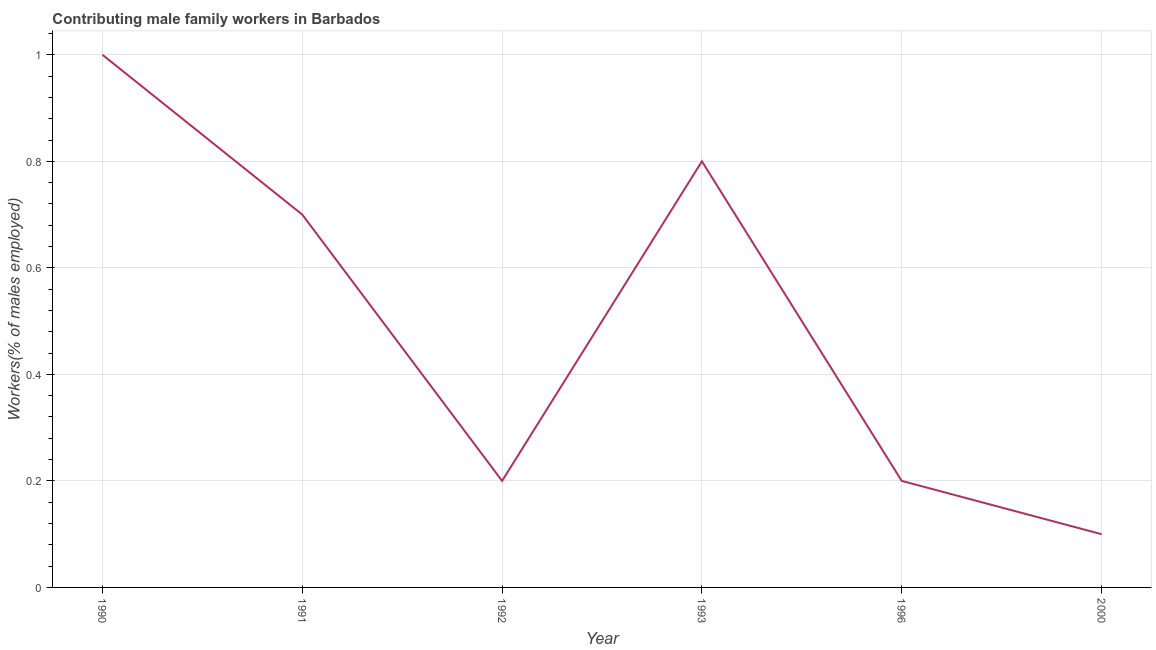Across all years, what is the minimum contributing male family workers?
Your answer should be very brief. 0.1. In which year was the contributing male family workers maximum?
Offer a terse response. 1990. In which year was the contributing male family workers minimum?
Your answer should be compact. 2000. What is the sum of the contributing male family workers?
Your answer should be very brief. 3. What is the difference between the contributing male family workers in 1991 and 1996?
Provide a short and direct response. 0.5. What is the average contributing male family workers per year?
Offer a very short reply. 0.5. What is the median contributing male family workers?
Keep it short and to the point. 0.45. Do a majority of the years between 1992 and 1991 (inclusive) have contributing male family workers greater than 0.48000000000000004 %?
Keep it short and to the point. No. What is the ratio of the contributing male family workers in 1990 to that in 2000?
Your answer should be compact. 10. What is the difference between the highest and the second highest contributing male family workers?
Keep it short and to the point. 0.2. Is the sum of the contributing male family workers in 1991 and 1992 greater than the maximum contributing male family workers across all years?
Give a very brief answer. No. What is the difference between the highest and the lowest contributing male family workers?
Your answer should be very brief. 0.9. Does the contributing male family workers monotonically increase over the years?
Keep it short and to the point. No. What is the title of the graph?
Your answer should be compact. Contributing male family workers in Barbados. What is the label or title of the X-axis?
Your answer should be compact. Year. What is the label or title of the Y-axis?
Offer a very short reply. Workers(% of males employed). What is the Workers(% of males employed) in 1990?
Make the answer very short. 1. What is the Workers(% of males employed) of 1991?
Ensure brevity in your answer.  0.7. What is the Workers(% of males employed) of 1992?
Your answer should be compact. 0.2. What is the Workers(% of males employed) in 1993?
Your response must be concise. 0.8. What is the Workers(% of males employed) in 1996?
Your answer should be compact. 0.2. What is the Workers(% of males employed) in 2000?
Provide a succinct answer. 0.1. What is the difference between the Workers(% of males employed) in 1990 and 2000?
Provide a succinct answer. 0.9. What is the difference between the Workers(% of males employed) in 1991 and 1992?
Offer a terse response. 0.5. What is the difference between the Workers(% of males employed) in 1991 and 1996?
Ensure brevity in your answer.  0.5. What is the difference between the Workers(% of males employed) in 1991 and 2000?
Provide a succinct answer. 0.6. What is the difference between the Workers(% of males employed) in 1992 and 1993?
Make the answer very short. -0.6. What is the difference between the Workers(% of males employed) in 1992 and 2000?
Ensure brevity in your answer.  0.1. What is the difference between the Workers(% of males employed) in 1993 and 2000?
Offer a terse response. 0.7. What is the difference between the Workers(% of males employed) in 1996 and 2000?
Your response must be concise. 0.1. What is the ratio of the Workers(% of males employed) in 1990 to that in 1991?
Your answer should be very brief. 1.43. What is the ratio of the Workers(% of males employed) in 1990 to that in 2000?
Make the answer very short. 10. What is the ratio of the Workers(% of males employed) in 1991 to that in 1996?
Your response must be concise. 3.5. What is the ratio of the Workers(% of males employed) in 1992 to that in 1993?
Offer a very short reply. 0.25. 